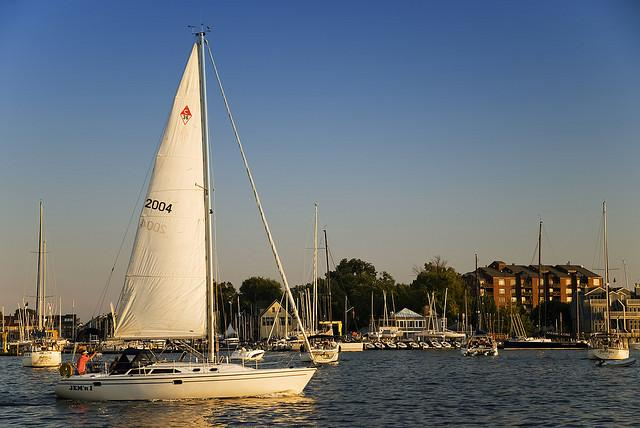What material is the sail mast made of? canvas 